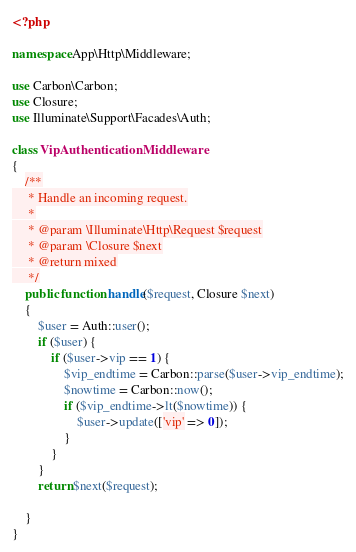Convert code to text. <code><loc_0><loc_0><loc_500><loc_500><_PHP_><?php

namespace App\Http\Middleware;

use Carbon\Carbon;
use Closure;
use Illuminate\Support\Facades\Auth;

class VipAuthenticationMiddleware
{
    /**
     * Handle an incoming request.
     *
     * @param \Illuminate\Http\Request $request
     * @param \Closure $next
     * @return mixed
     */
    public function handle($request, Closure $next)
    {
        $user = Auth::user();
        if ($user) {
            if ($user->vip == 1) {
                $vip_endtime = Carbon::parse($user->vip_endtime);
                $nowtime = Carbon::now();
                if ($vip_endtime->lt($nowtime)) {
                    $user->update(['vip' => 0]);
                }
            }
        }
        return $next($request);

    }
}
</code> 